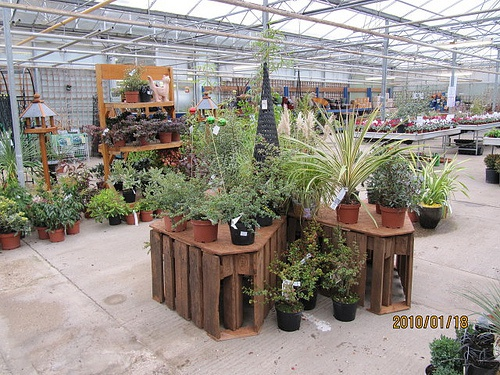Describe the objects in this image and their specific colors. I can see potted plant in lightgray, gray, black, darkgray, and olive tones, potted plant in lightgray, olive, darkgray, and gray tones, potted plant in lightgray, black, darkgreen, and gray tones, potted plant in lightgray, gray, black, and olive tones, and potted plant in lightgray, darkgray, black, and olive tones in this image. 